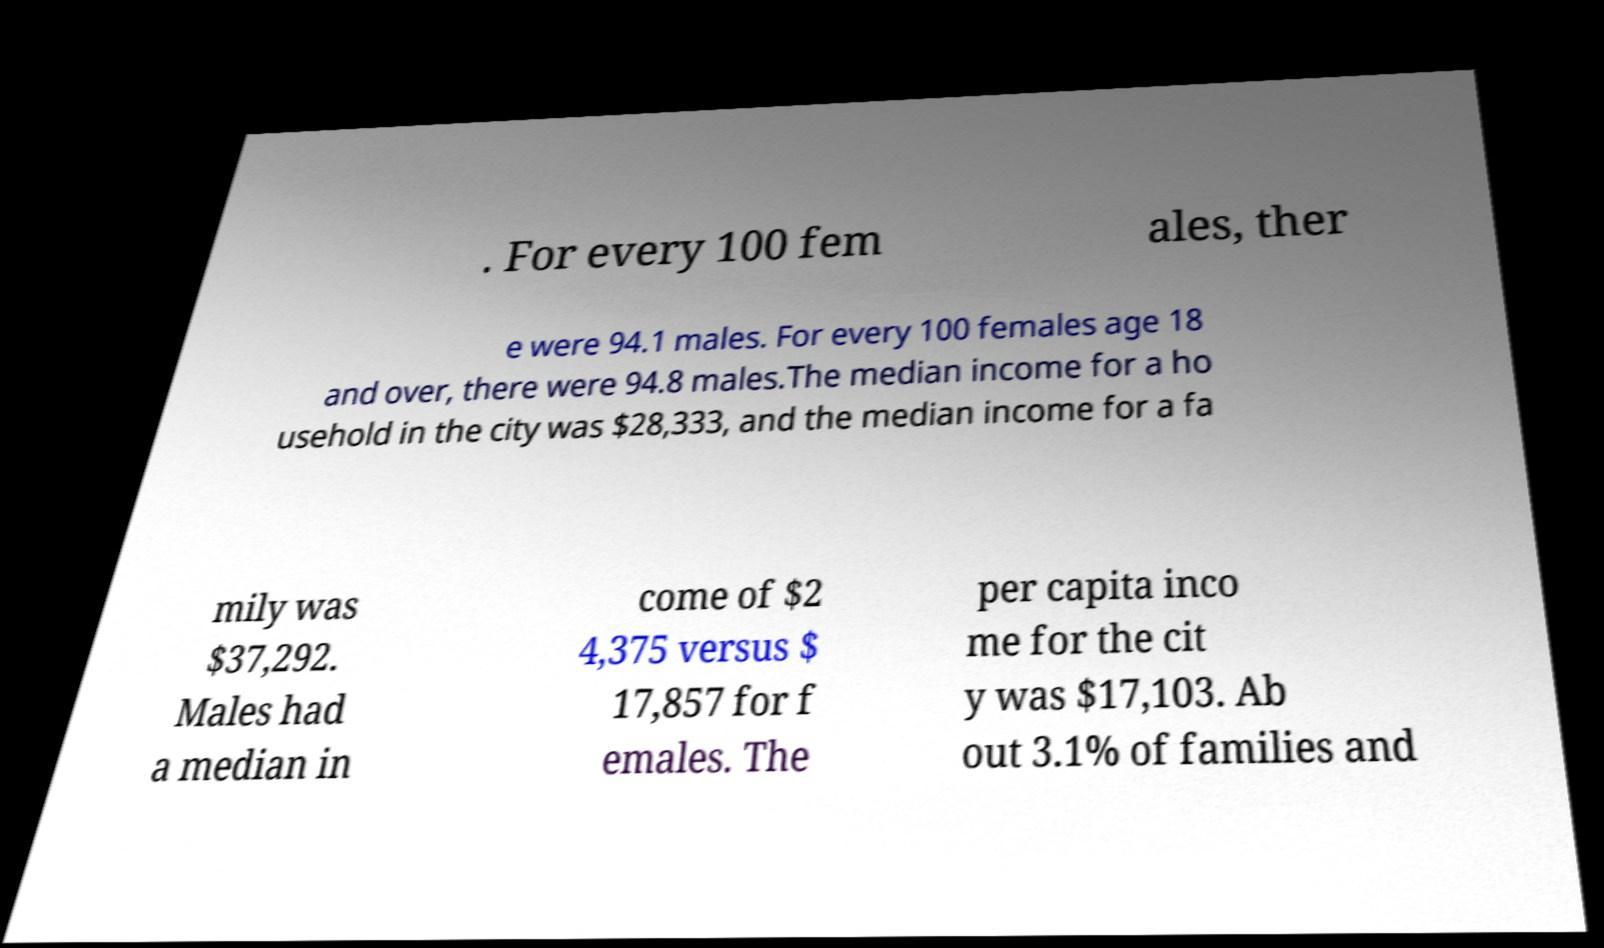For documentation purposes, I need the text within this image transcribed. Could you provide that? . For every 100 fem ales, ther e were 94.1 males. For every 100 females age 18 and over, there were 94.8 males.The median income for a ho usehold in the city was $28,333, and the median income for a fa mily was $37,292. Males had a median in come of $2 4,375 versus $ 17,857 for f emales. The per capita inco me for the cit y was $17,103. Ab out 3.1% of families and 